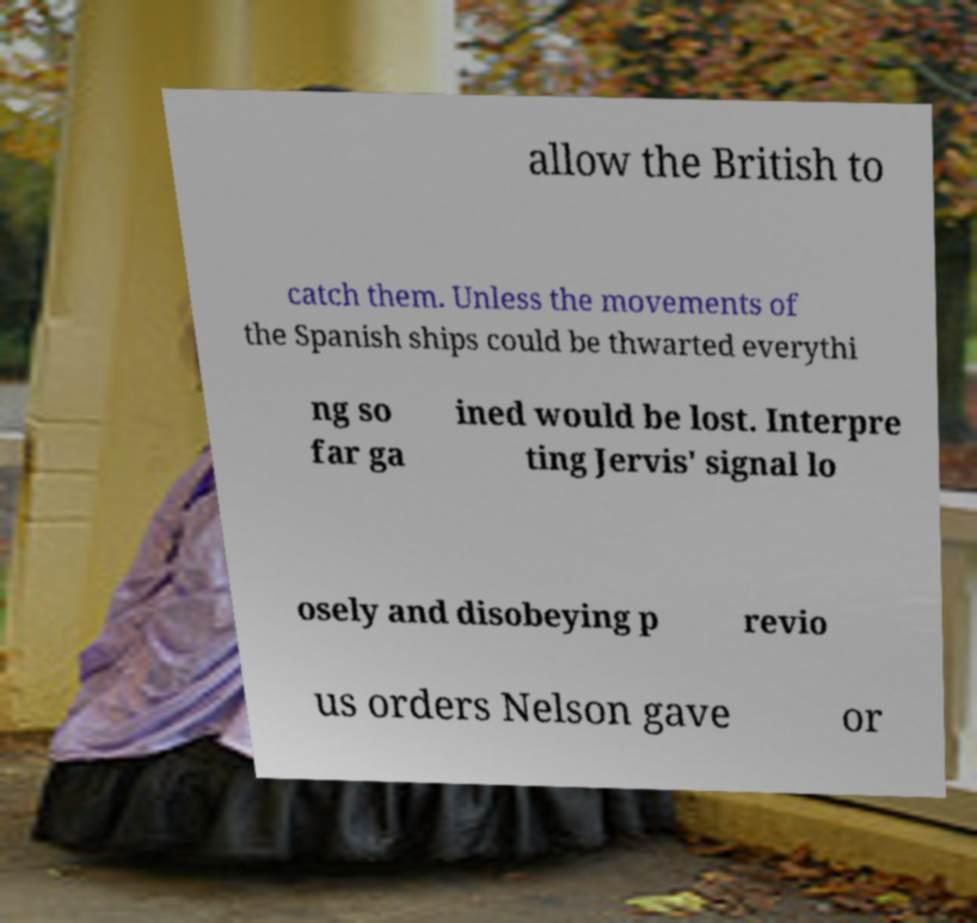Please identify and transcribe the text found in this image. allow the British to catch them. Unless the movements of the Spanish ships could be thwarted everythi ng so far ga ined would be lost. Interpre ting Jervis' signal lo osely and disobeying p revio us orders Nelson gave or 